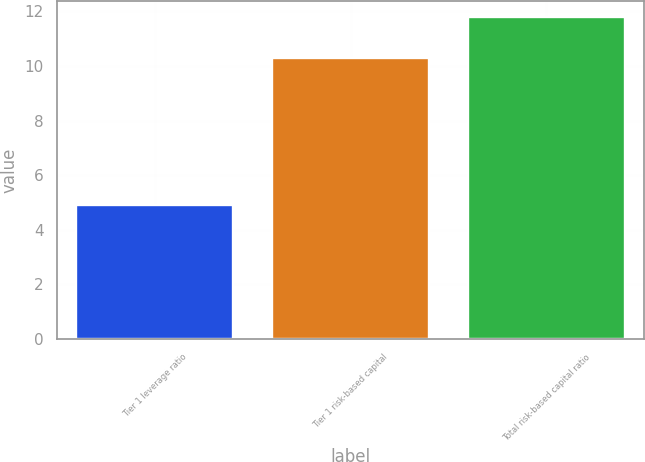<chart> <loc_0><loc_0><loc_500><loc_500><bar_chart><fcel>Tier 1 leverage ratio<fcel>Tier 1 risk-based capital<fcel>Total risk-based capital ratio<nl><fcel>4.9<fcel>10.3<fcel>11.8<nl></chart> 